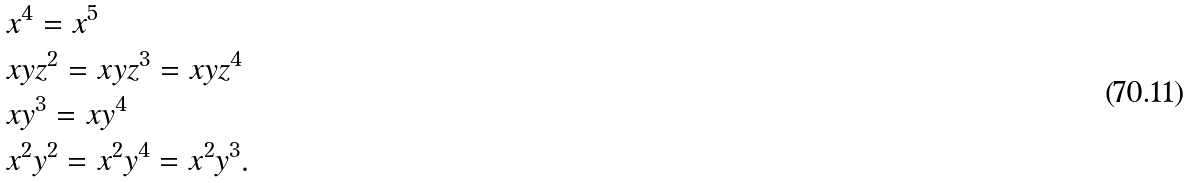Convert formula to latex. <formula><loc_0><loc_0><loc_500><loc_500>& x ^ { 4 } = x ^ { 5 } \\ & x y z ^ { 2 } = x y z ^ { 3 } = x y z ^ { 4 } \\ & x y ^ { 3 } = x y ^ { 4 } \\ & x ^ { 2 } y ^ { 2 } = x ^ { 2 } y ^ { 4 } = x ^ { 2 } y ^ { 3 } .</formula> 